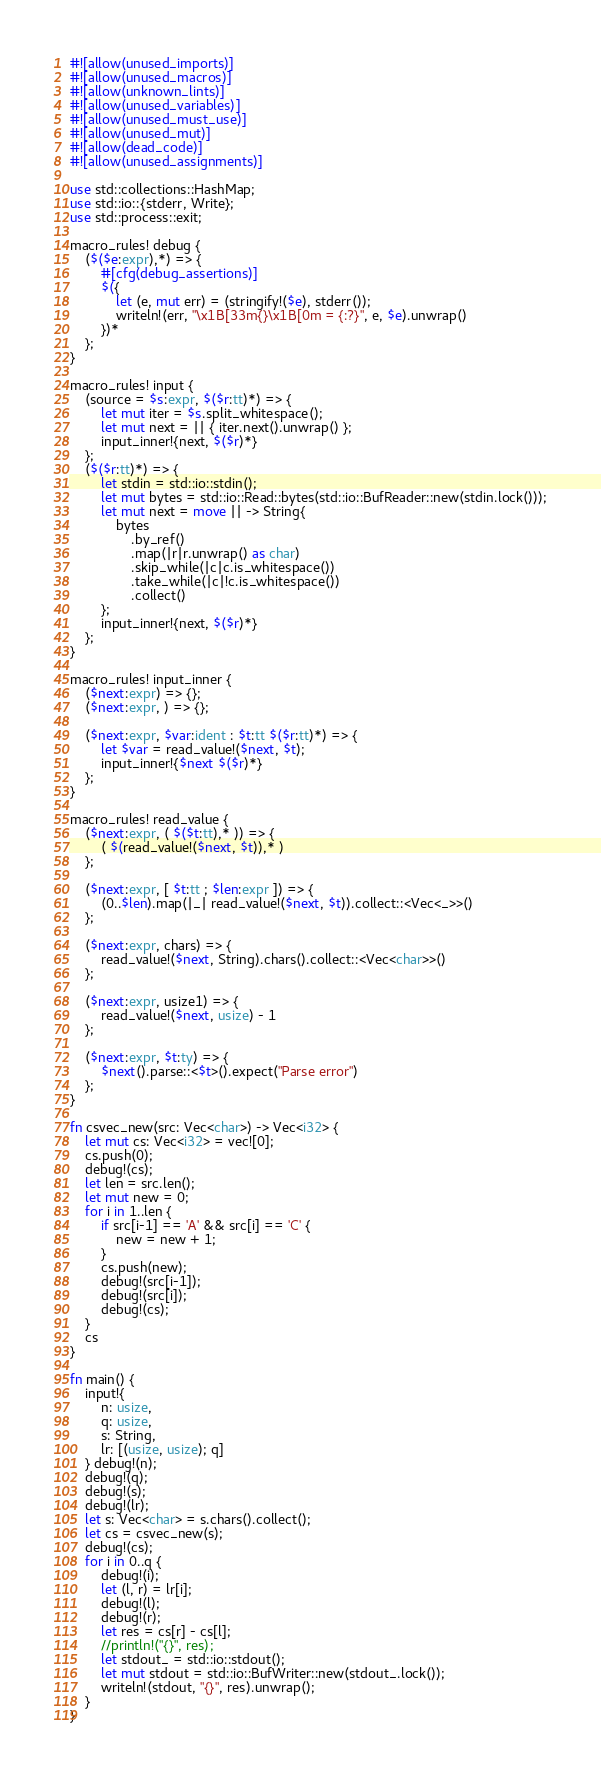<code> <loc_0><loc_0><loc_500><loc_500><_Rust_>#![allow(unused_imports)]
#![allow(unused_macros)]
#![allow(unknown_lints)]
#![allow(unused_variables)]
#![allow(unused_must_use)]
#![allow(unused_mut)]
#![allow(dead_code)]
#![allow(unused_assignments)]

use std::collections::HashMap;
use std::io::{stderr, Write};
use std::process::exit;

macro_rules! debug {
    ($($e:expr),*) => {
        #[cfg(debug_assertions)]
        $({
            let (e, mut err) = (stringify!($e), stderr());
            writeln!(err, "\x1B[33m{}\x1B[0m = {:?}", e, $e).unwrap()
        })*
    };
}

macro_rules! input {
    (source = $s:expr, $($r:tt)*) => {
        let mut iter = $s.split_whitespace();
        let mut next = || { iter.next().unwrap() };
        input_inner!{next, $($r)*}
    };
    ($($r:tt)*) => {
        let stdin = std::io::stdin();
        let mut bytes = std::io::Read::bytes(std::io::BufReader::new(stdin.lock()));
        let mut next = move || -> String{
            bytes
                .by_ref()
                .map(|r|r.unwrap() as char)
                .skip_while(|c|c.is_whitespace())
                .take_while(|c|!c.is_whitespace())
                .collect()
        };
        input_inner!{next, $($r)*}
    };
}

macro_rules! input_inner {
    ($next:expr) => {};
    ($next:expr, ) => {};

    ($next:expr, $var:ident : $t:tt $($r:tt)*) => {
        let $var = read_value!($next, $t);
        input_inner!{$next $($r)*}
    };
}

macro_rules! read_value {
    ($next:expr, ( $($t:tt),* )) => {
        ( $(read_value!($next, $t)),* )
    };

    ($next:expr, [ $t:tt ; $len:expr ]) => {
        (0..$len).map(|_| read_value!($next, $t)).collect::<Vec<_>>()
    };

    ($next:expr, chars) => {
        read_value!($next, String).chars().collect::<Vec<char>>()
    };

    ($next:expr, usize1) => {
        read_value!($next, usize) - 1
    };

    ($next:expr, $t:ty) => {
        $next().parse::<$t>().expect("Parse error")
    };
}

fn csvec_new(src: Vec<char>) -> Vec<i32> {
    let mut cs: Vec<i32> = vec![0];
    cs.push(0);
    debug!(cs);
    let len = src.len();
    let mut new = 0;
    for i in 1..len {
        if src[i-1] == 'A' && src[i] == 'C' {
            new = new + 1;
        }
        cs.push(new);
        debug!(src[i-1]);
        debug!(src[i]);
        debug!(cs);
    }
    cs
}

fn main() {
    input!{
        n: usize,
        q: usize,
        s: String,
        lr: [(usize, usize); q]
    } debug!(n);
    debug!(q);
    debug!(s);
    debug!(lr);
    let s: Vec<char> = s.chars().collect();
    let cs = csvec_new(s);
    debug!(cs);
    for i in 0..q {
        debug!(i);
        let (l, r) = lr[i];
        debug!(l);
        debug!(r);
        let res = cs[r] - cs[l];
        //println!("{}", res);
        let stdout_ = std::io::stdout();
        let mut stdout = std::io::BufWriter::new(stdout_.lock());
        writeln!(stdout, "{}", res).unwrap();
    }
}</code> 